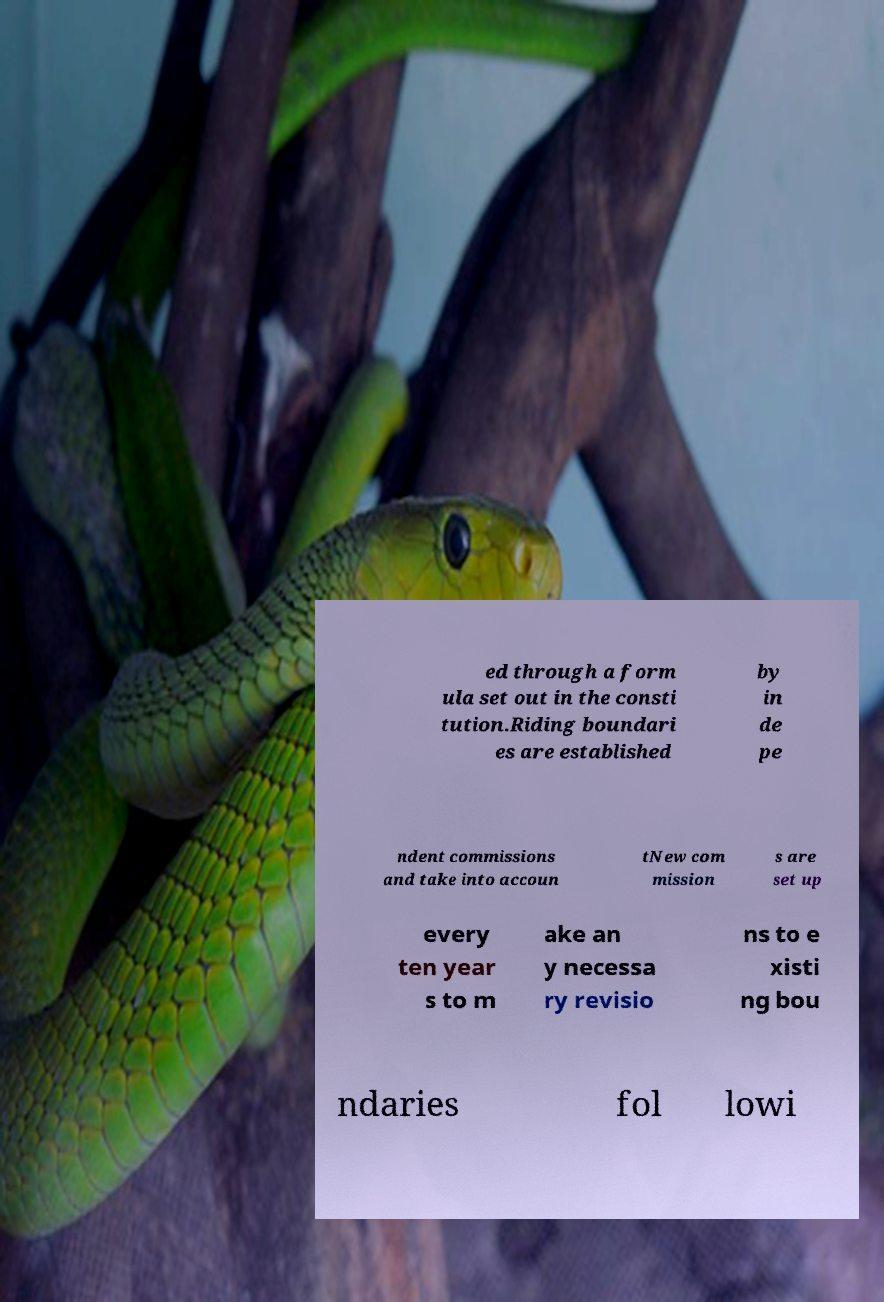There's text embedded in this image that I need extracted. Can you transcribe it verbatim? ed through a form ula set out in the consti tution.Riding boundari es are established by in de pe ndent commissions and take into accoun tNew com mission s are set up every ten year s to m ake an y necessa ry revisio ns to e xisti ng bou ndaries fol lowi 